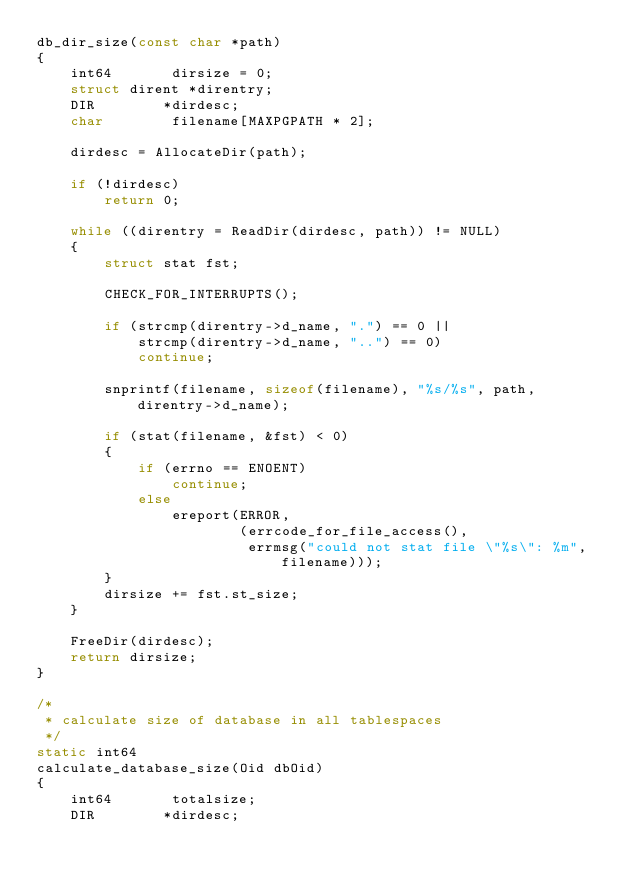Convert code to text. <code><loc_0><loc_0><loc_500><loc_500><_C_>db_dir_size(const char *path)
{
	int64		dirsize = 0;
	struct dirent *direntry;
	DIR		   *dirdesc;
	char		filename[MAXPGPATH * 2];

	dirdesc = AllocateDir(path);

	if (!dirdesc)
		return 0;

	while ((direntry = ReadDir(dirdesc, path)) != NULL)
	{
		struct stat fst;

		CHECK_FOR_INTERRUPTS();

		if (strcmp(direntry->d_name, ".") == 0 ||
			strcmp(direntry->d_name, "..") == 0)
			continue;

		snprintf(filename, sizeof(filename), "%s/%s", path, direntry->d_name);

		if (stat(filename, &fst) < 0)
		{
			if (errno == ENOENT)
				continue;
			else
				ereport(ERROR,
						(errcode_for_file_access(),
						 errmsg("could not stat file \"%s\": %m", filename)));
		}
		dirsize += fst.st_size;
	}

	FreeDir(dirdesc);
	return dirsize;
}

/*
 * calculate size of database in all tablespaces
 */
static int64
calculate_database_size(Oid dbOid)
{
	int64		totalsize;
	DIR		   *dirdesc;</code> 